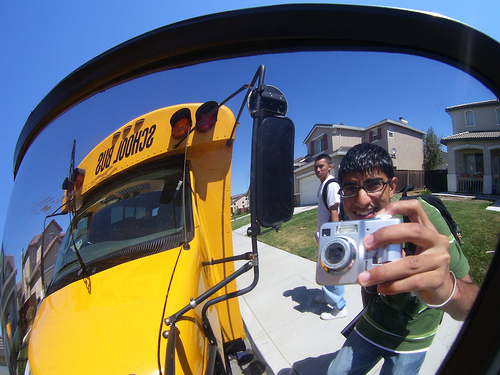Please provide a short description for this region: [0.67, 0.41, 0.75, 0.47]. This region shows the hair of a student, which is visible in the image. 